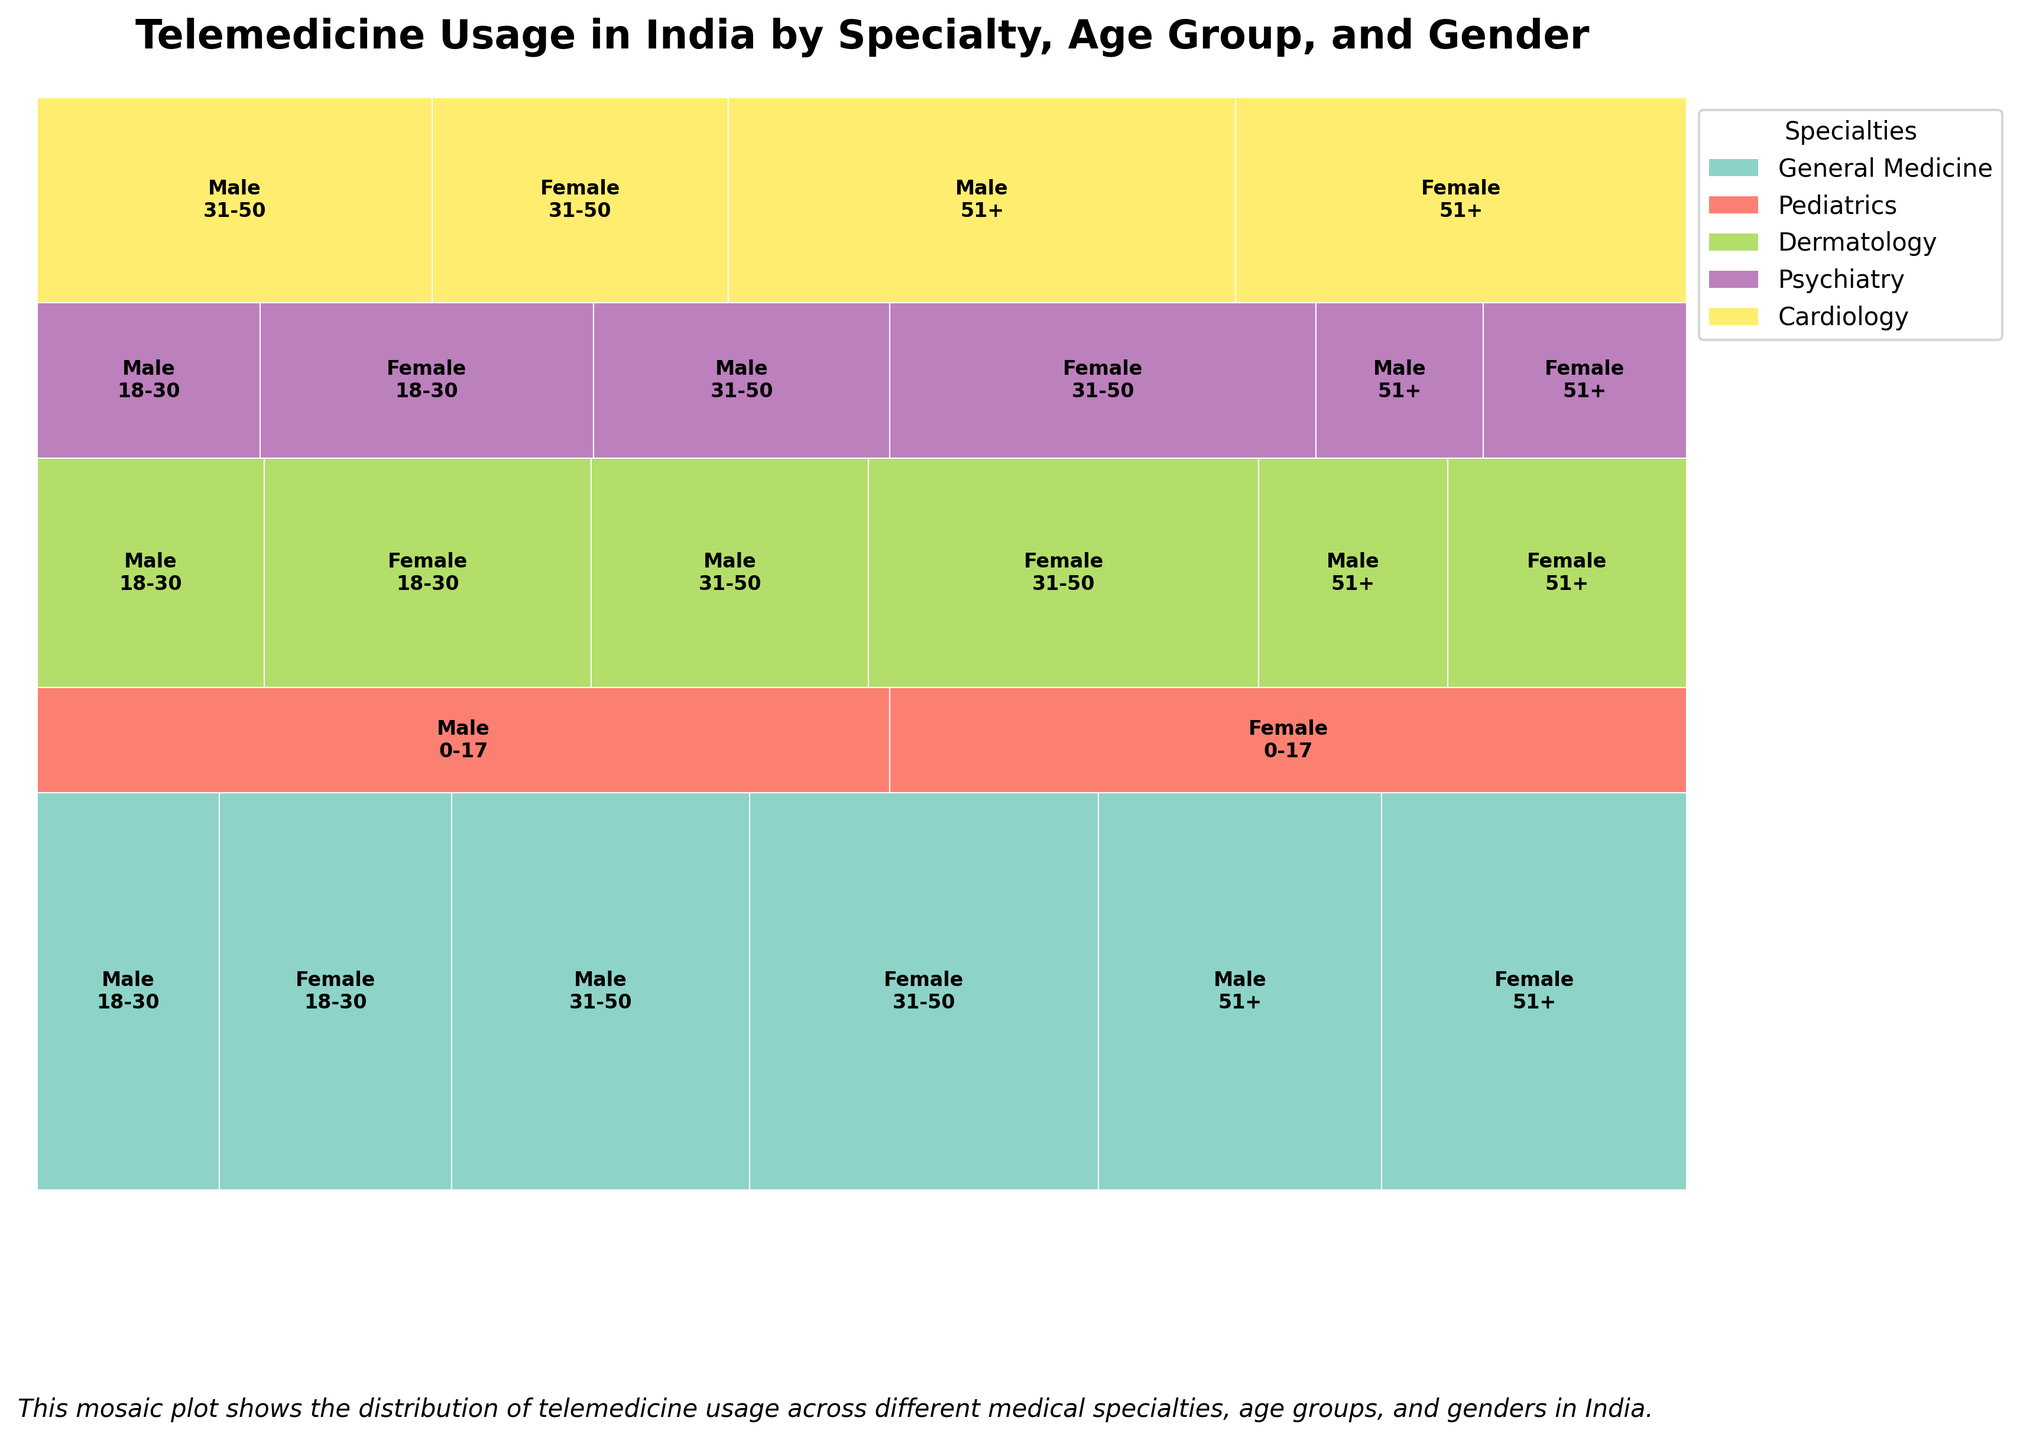What medical specialties are represented in the plot? The legend on the right side of the plot shows the different medical specialties. By inspecting it, one can identify the represented specialties.
Answer: General Medicine, Pediatrics, Dermatology, Psychiatry, Cardiology Which age group has the highest usage of telemedicine services in General Medicine? By looking at the sections for General Medicine, find the age group with the largest proportion of the rectangles.
Answer: 31-50 Among the Pediatrics specialty, between male and female, who uses telemedicine services more? Observe the size of the rectangles for male and female within the Pediatrics section. The larger rectangle indicates higher usage.
Answer: Male How does telemedicine usage for Dermatology compare between the age groups 18-30 and 51+ for females? Compare the size of the rectangles within Dermatology for females across these age groups. The larger rectangle indicates higher usage.
Answer: 18-30 has higher usage than 51+ Which medical specialty shows the least variation in telemedicine usage across different age groups and genders? Observe which specialty has the most uniformly sized rectangles, indicating less variation.
Answer: Psychiatry Within General Medicine, which gender shows higher telemedicine usage in the 51+ age group? Compare the rectangles for males and females in General Medicine and the 51+ age group. The larger rectangle indicates higher usage.
Answer: Female What's the total telemedicine usage for Psychiatrists across all age groups and genders? Sum up the values in the Psychiatry row for both genders in all age groups: (1200 + 1800 + 1600 + 2300 + 900 + 1100)
Answer: 8900 For Cardiology, which age group shows the highest telemedicine usage for males? Compare the male age group rectangles within the Cardiology section to find the largest one.
Answer: 51+ What is the most used specialty through telemedicine for the age group 31-50? Compare the rectangles of all specialties for the age group 31-50 to find the largest one.
Answer: General Medicine How does telemedicine usage between males and females within Dermatology specialty compare for the age group 31-50? Compare the size of the rectangles for males and females in Dermatology, age group 31-50. Identify the larger rectangle.
Answer: Female 